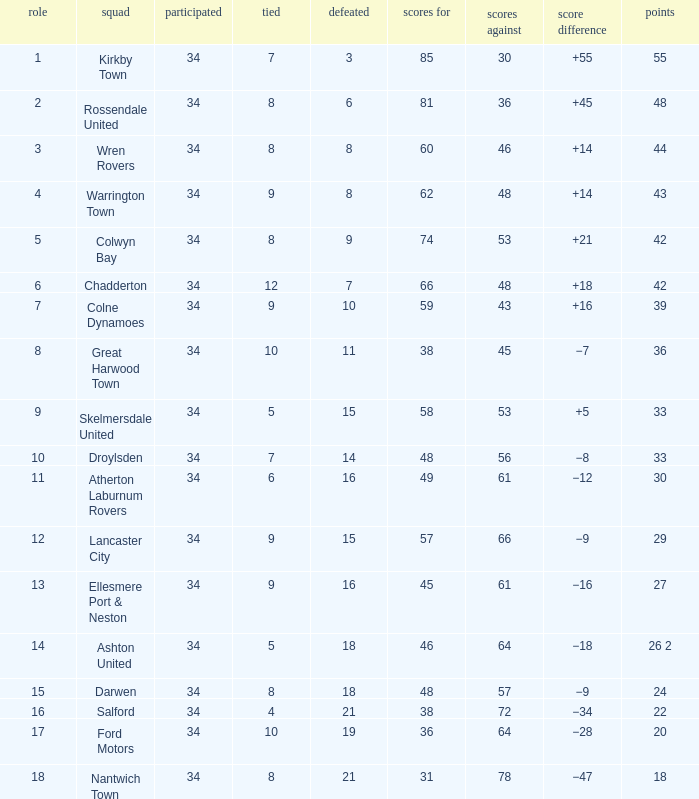Parse the full table. {'header': ['role', 'squad', 'participated', 'tied', 'defeated', 'scores for', 'scores against', 'score difference', 'points'], 'rows': [['1', 'Kirkby Town', '34', '7', '3', '85', '30', '+55', '55'], ['2', 'Rossendale United', '34', '8', '6', '81', '36', '+45', '48'], ['3', 'Wren Rovers', '34', '8', '8', '60', '46', '+14', '44'], ['4', 'Warrington Town', '34', '9', '8', '62', '48', '+14', '43'], ['5', 'Colwyn Bay', '34', '8', '9', '74', '53', '+21', '42'], ['6', 'Chadderton', '34', '12', '7', '66', '48', '+18', '42'], ['7', 'Colne Dynamoes', '34', '9', '10', '59', '43', '+16', '39'], ['8', 'Great Harwood Town', '34', '10', '11', '38', '45', '−7', '36'], ['9', 'Skelmersdale United', '34', '5', '15', '58', '53', '+5', '33'], ['10', 'Droylsden', '34', '7', '14', '48', '56', '−8', '33'], ['11', 'Atherton Laburnum Rovers', '34', '6', '16', '49', '61', '−12', '30'], ['12', 'Lancaster City', '34', '9', '15', '57', '66', '−9', '29'], ['13', 'Ellesmere Port & Neston', '34', '9', '16', '45', '61', '−16', '27'], ['14', 'Ashton United', '34', '5', '18', '46', '64', '−18', '26 2'], ['15', 'Darwen', '34', '8', '18', '48', '57', '−9', '24'], ['16', 'Salford', '34', '4', '21', '38', '72', '−34', '22'], ['17', 'Ford Motors', '34', '10', '19', '36', '64', '−28', '20'], ['18', 'Nantwich Town', '34', '8', '21', '31', '78', '−47', '18']]} What is the cumulative count of positions when over 48 goals are scored against, 1 out of 29 points is played, and under 34 games are completed? 0.0. 